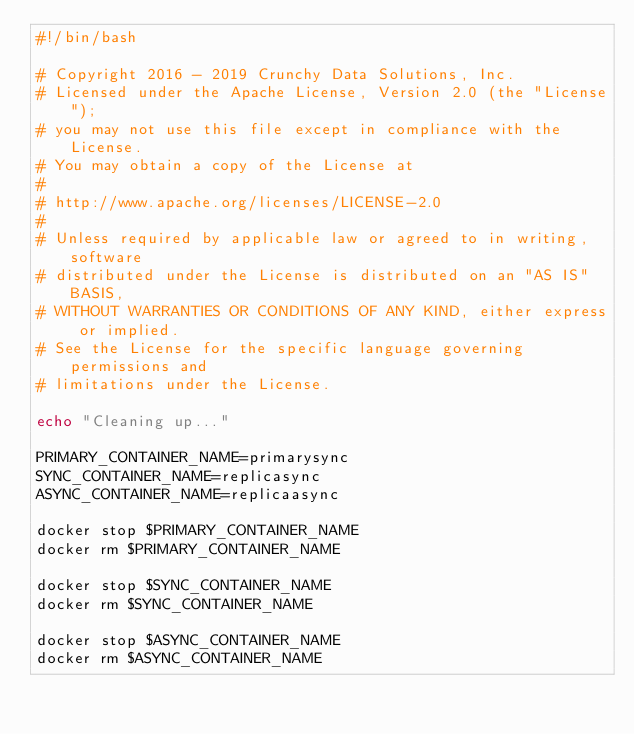Convert code to text. <code><loc_0><loc_0><loc_500><loc_500><_Bash_>#!/bin/bash

# Copyright 2016 - 2019 Crunchy Data Solutions, Inc.
# Licensed under the Apache License, Version 2.0 (the "License");
# you may not use this file except in compliance with the License.
# You may obtain a copy of the License at
#
# http://www.apache.org/licenses/LICENSE-2.0
#
# Unless required by applicable law or agreed to in writing, software
# distributed under the License is distributed on an "AS IS" BASIS,
# WITHOUT WARRANTIES OR CONDITIONS OF ANY KIND, either express or implied.
# See the License for the specific language governing permissions and
# limitations under the License.

echo "Cleaning up..."

PRIMARY_CONTAINER_NAME=primarysync
SYNC_CONTAINER_NAME=replicasync
ASYNC_CONTAINER_NAME=replicaasync

docker stop $PRIMARY_CONTAINER_NAME
docker rm $PRIMARY_CONTAINER_NAME

docker stop $SYNC_CONTAINER_NAME
docker rm $SYNC_CONTAINER_NAME

docker stop $ASYNC_CONTAINER_NAME
docker rm $ASYNC_CONTAINER_NAME
</code> 